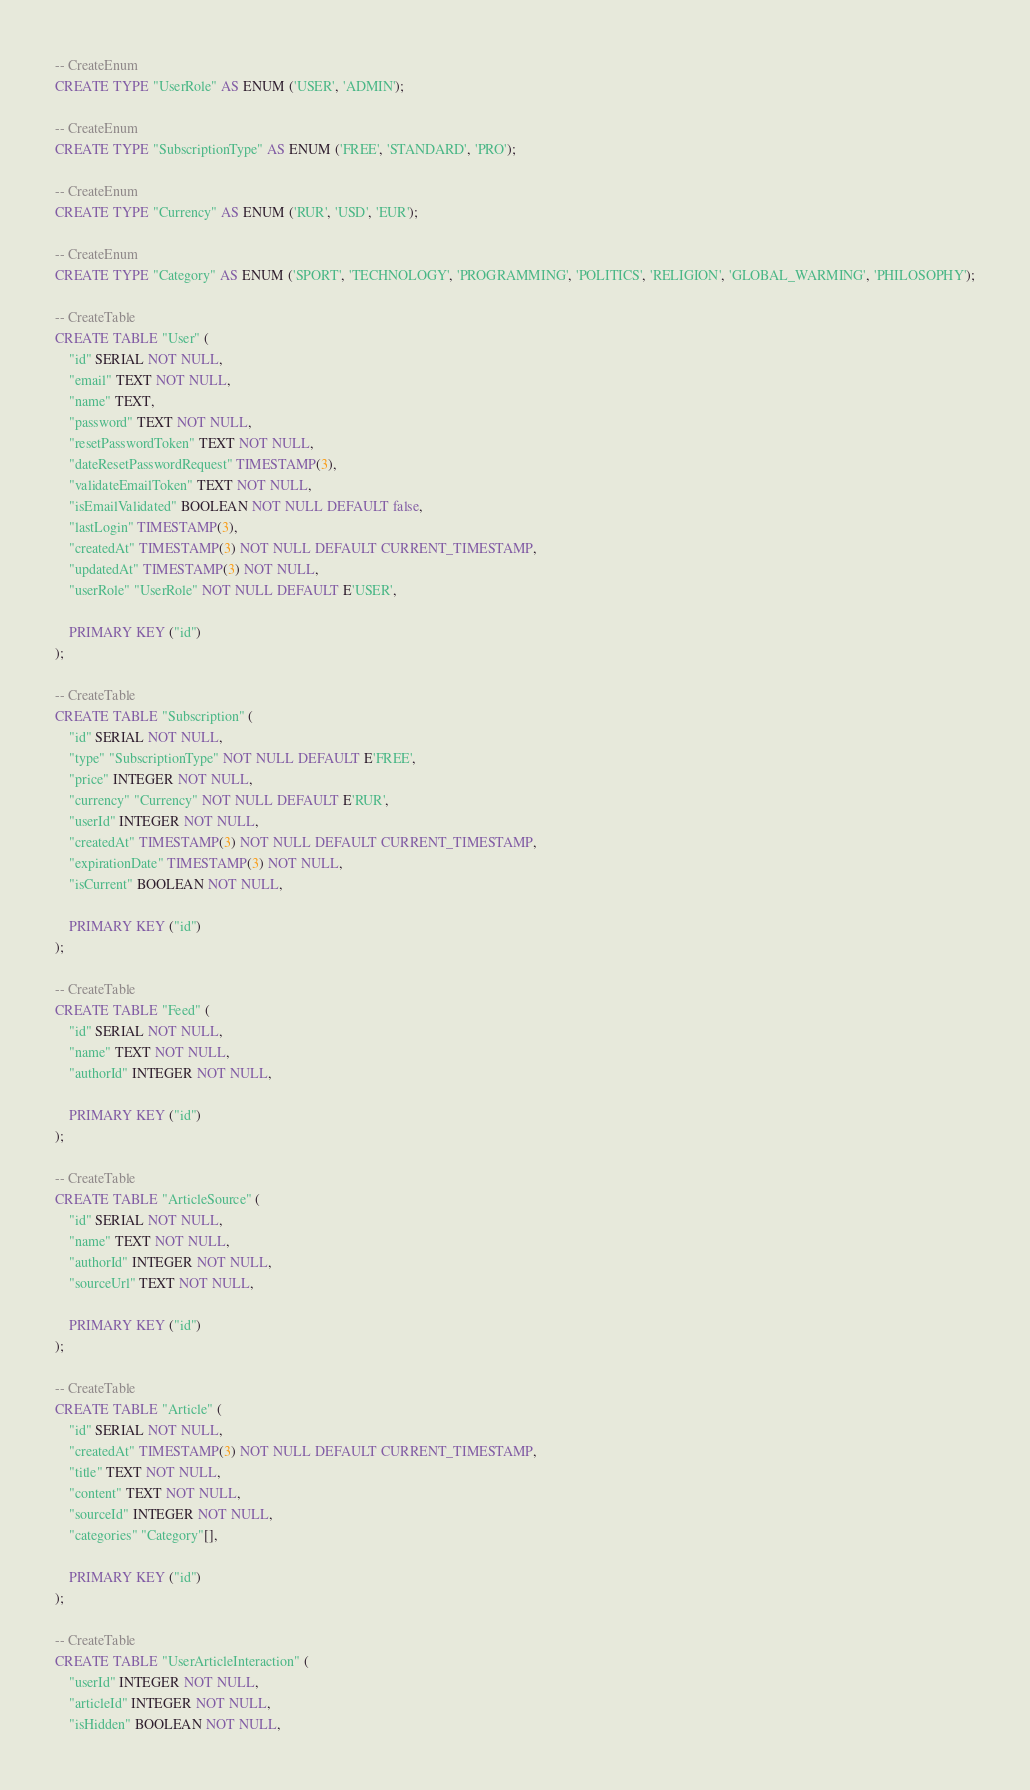Convert code to text. <code><loc_0><loc_0><loc_500><loc_500><_SQL_>-- CreateEnum
CREATE TYPE "UserRole" AS ENUM ('USER', 'ADMIN');

-- CreateEnum
CREATE TYPE "SubscriptionType" AS ENUM ('FREE', 'STANDARD', 'PRO');

-- CreateEnum
CREATE TYPE "Currency" AS ENUM ('RUR', 'USD', 'EUR');

-- CreateEnum
CREATE TYPE "Category" AS ENUM ('SPORT', 'TECHNOLOGY', 'PROGRAMMING', 'POLITICS', 'RELIGION', 'GLOBAL_WARMING', 'PHILOSOPHY');

-- CreateTable
CREATE TABLE "User" (
    "id" SERIAL NOT NULL,
    "email" TEXT NOT NULL,
    "name" TEXT,
    "password" TEXT NOT NULL,
    "resetPasswordToken" TEXT NOT NULL,
    "dateResetPasswordRequest" TIMESTAMP(3),
    "validateEmailToken" TEXT NOT NULL,
    "isEmailValidated" BOOLEAN NOT NULL DEFAULT false,
    "lastLogin" TIMESTAMP(3),
    "createdAt" TIMESTAMP(3) NOT NULL DEFAULT CURRENT_TIMESTAMP,
    "updatedAt" TIMESTAMP(3) NOT NULL,
    "userRole" "UserRole" NOT NULL DEFAULT E'USER',

    PRIMARY KEY ("id")
);

-- CreateTable
CREATE TABLE "Subscription" (
    "id" SERIAL NOT NULL,
    "type" "SubscriptionType" NOT NULL DEFAULT E'FREE',
    "price" INTEGER NOT NULL,
    "currency" "Currency" NOT NULL DEFAULT E'RUR',
    "userId" INTEGER NOT NULL,
    "createdAt" TIMESTAMP(3) NOT NULL DEFAULT CURRENT_TIMESTAMP,
    "expirationDate" TIMESTAMP(3) NOT NULL,
    "isCurrent" BOOLEAN NOT NULL,

    PRIMARY KEY ("id")
);

-- CreateTable
CREATE TABLE "Feed" (
    "id" SERIAL NOT NULL,
    "name" TEXT NOT NULL,
    "authorId" INTEGER NOT NULL,

    PRIMARY KEY ("id")
);

-- CreateTable
CREATE TABLE "ArticleSource" (
    "id" SERIAL NOT NULL,
    "name" TEXT NOT NULL,
    "authorId" INTEGER NOT NULL,
    "sourceUrl" TEXT NOT NULL,

    PRIMARY KEY ("id")
);

-- CreateTable
CREATE TABLE "Article" (
    "id" SERIAL NOT NULL,
    "createdAt" TIMESTAMP(3) NOT NULL DEFAULT CURRENT_TIMESTAMP,
    "title" TEXT NOT NULL,
    "content" TEXT NOT NULL,
    "sourceId" INTEGER NOT NULL,
    "categories" "Category"[],

    PRIMARY KEY ("id")
);

-- CreateTable
CREATE TABLE "UserArticleInteraction" (
    "userId" INTEGER NOT NULL,
    "articleId" INTEGER NOT NULL,
    "isHidden" BOOLEAN NOT NULL,</code> 